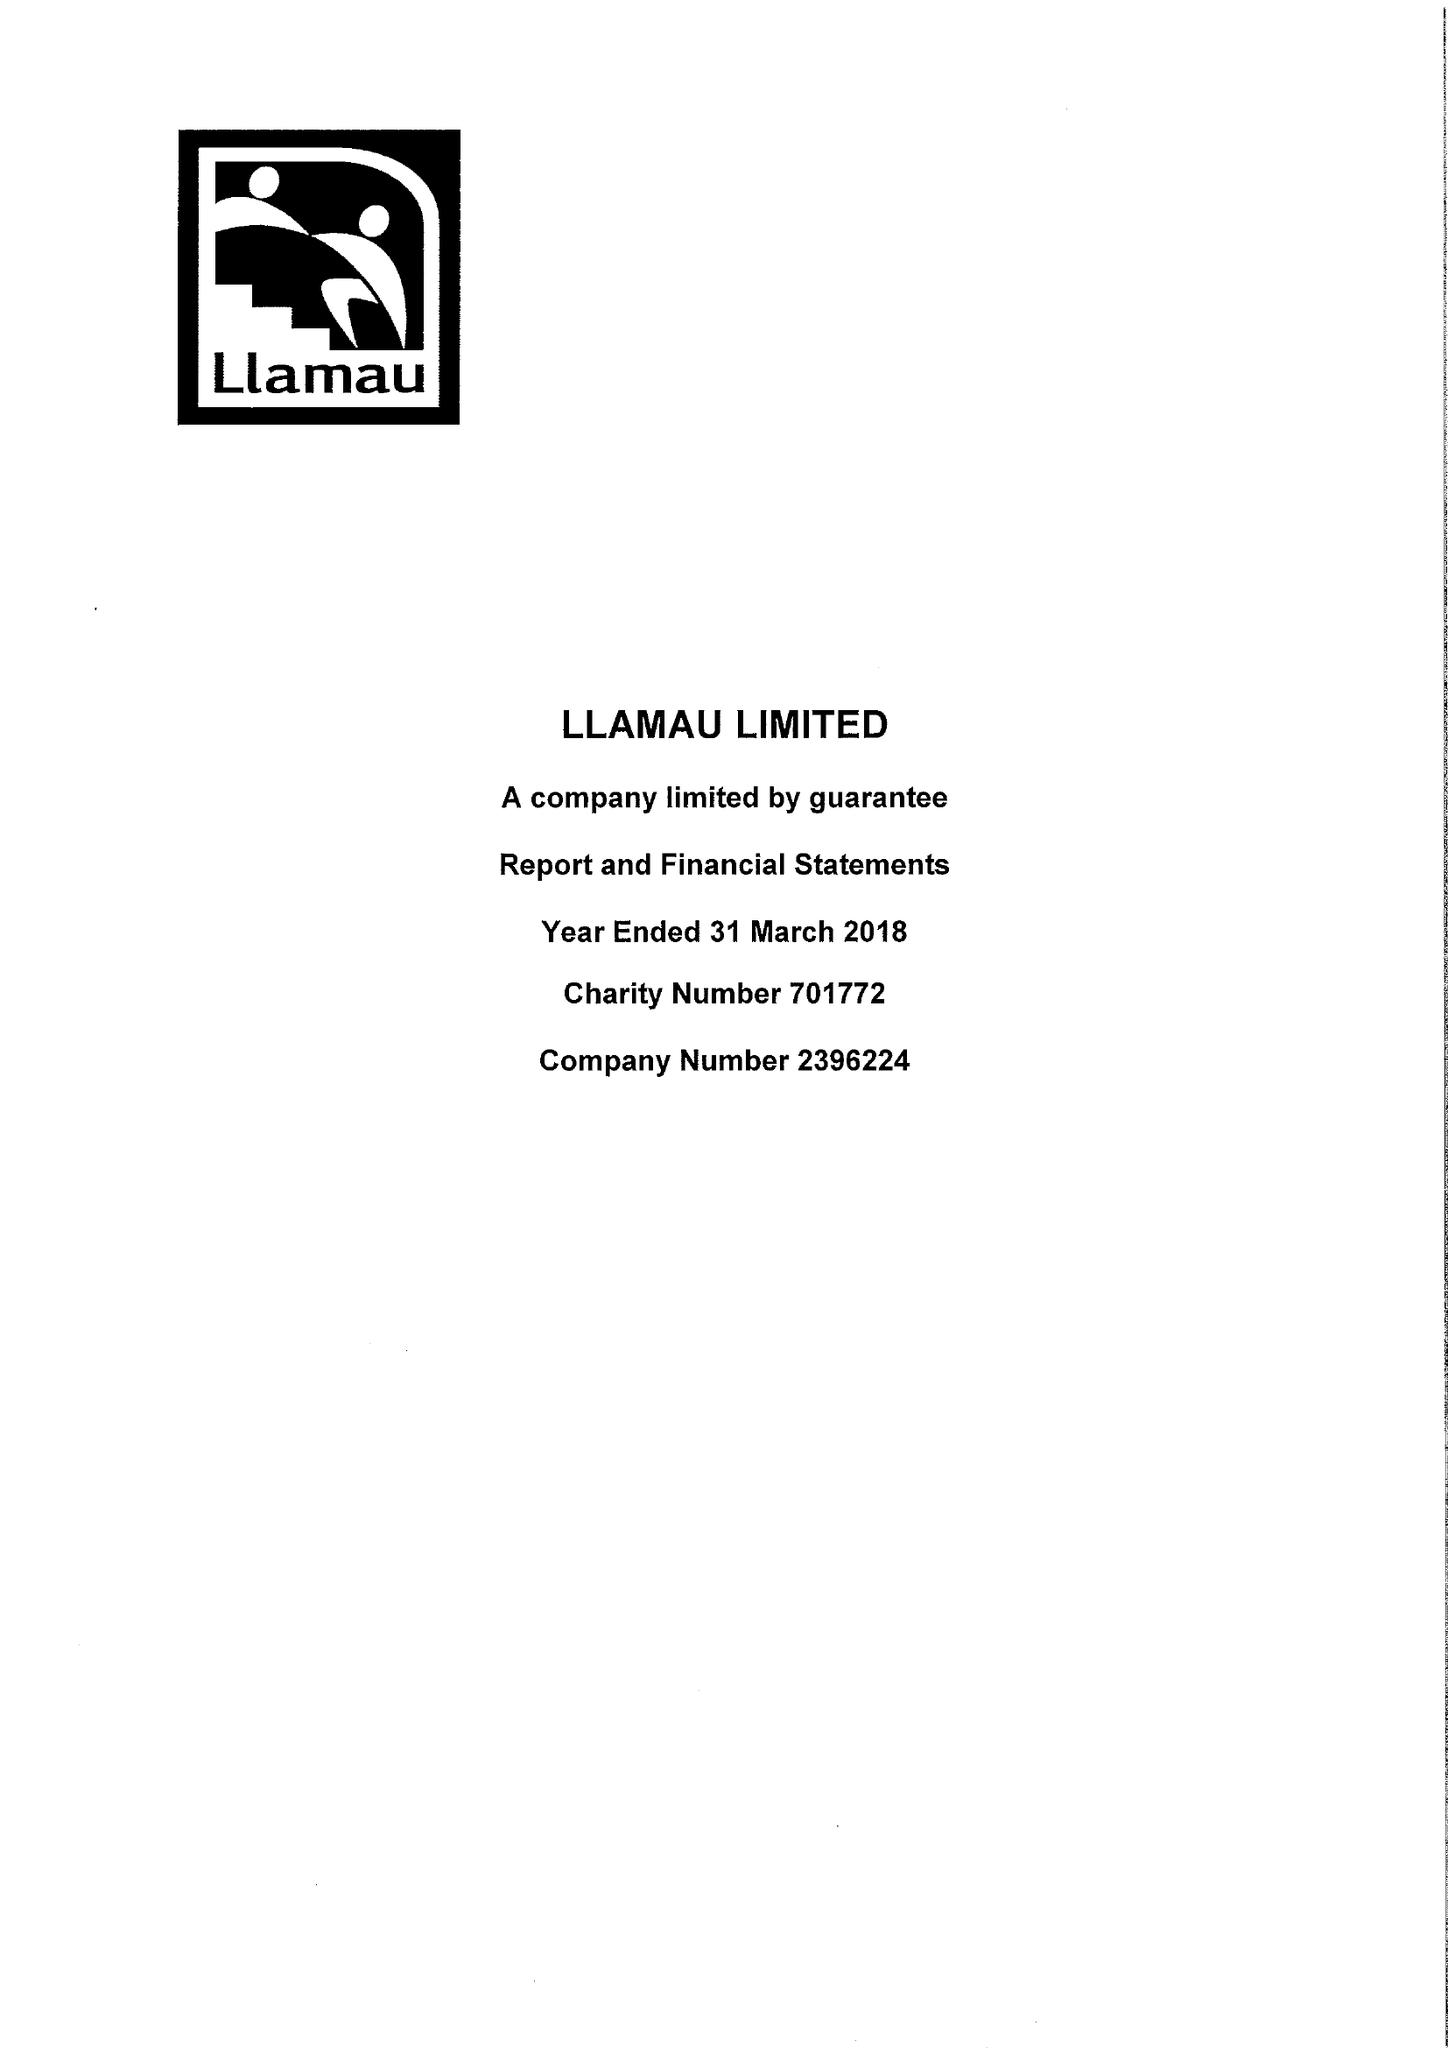What is the value for the address__postcode?
Answer the question using a single word or phrase. CF11 9HA 